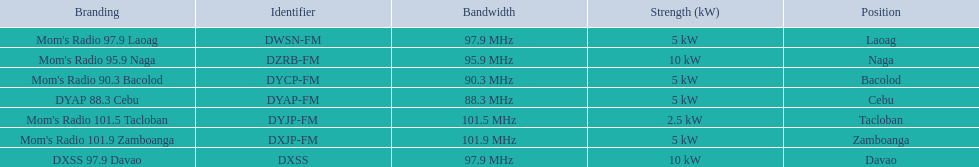What is the radio with the least about of mhz? DYAP 88.3 Cebu. 